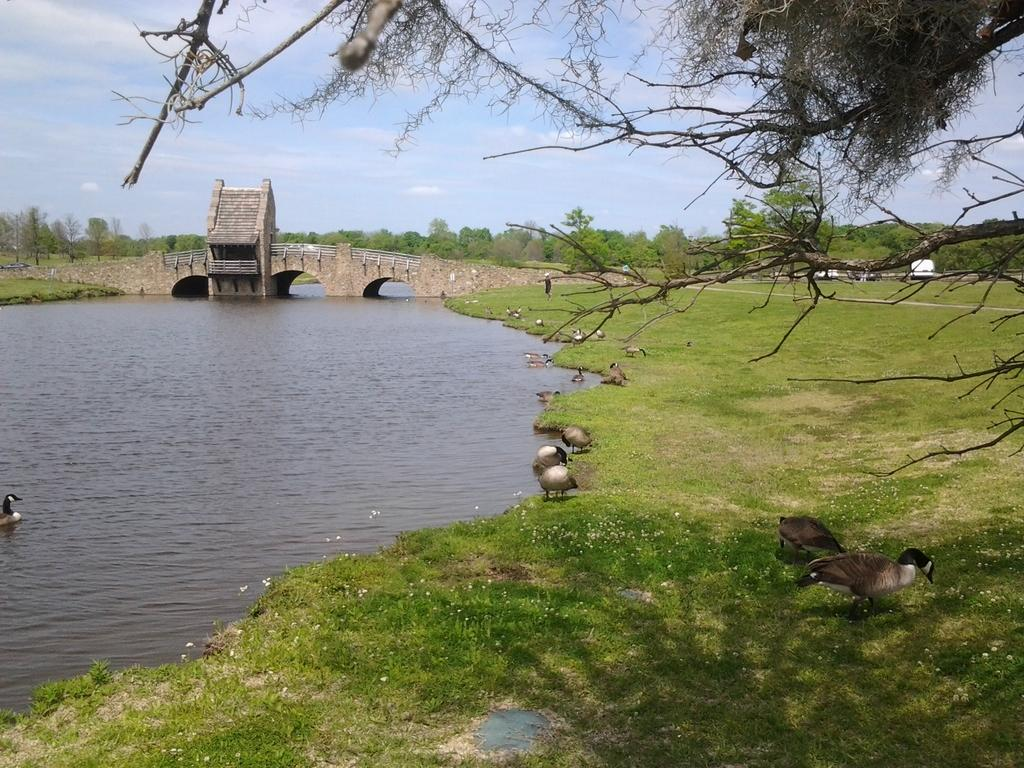What structure can be seen in the image? There is a bridge in the image. What natural element is visible in the image? There is water visible in the image. What type of vegetation is present in the image? There is grass in the image. What type of animals can be seen in the image? There are birds in the image. What other natural elements are present in the image? There are trees in the image. What is visible in the sky in the image? The sky is visible in the image, and there are clouds in the sky. What type of hook can be seen hanging from the bridge in the image? There is no hook visible hanging from the bridge in the image. What type of print is visible on the birds in the image? There are no prints visible on the birds in the image; they are simply depicted as birds. 